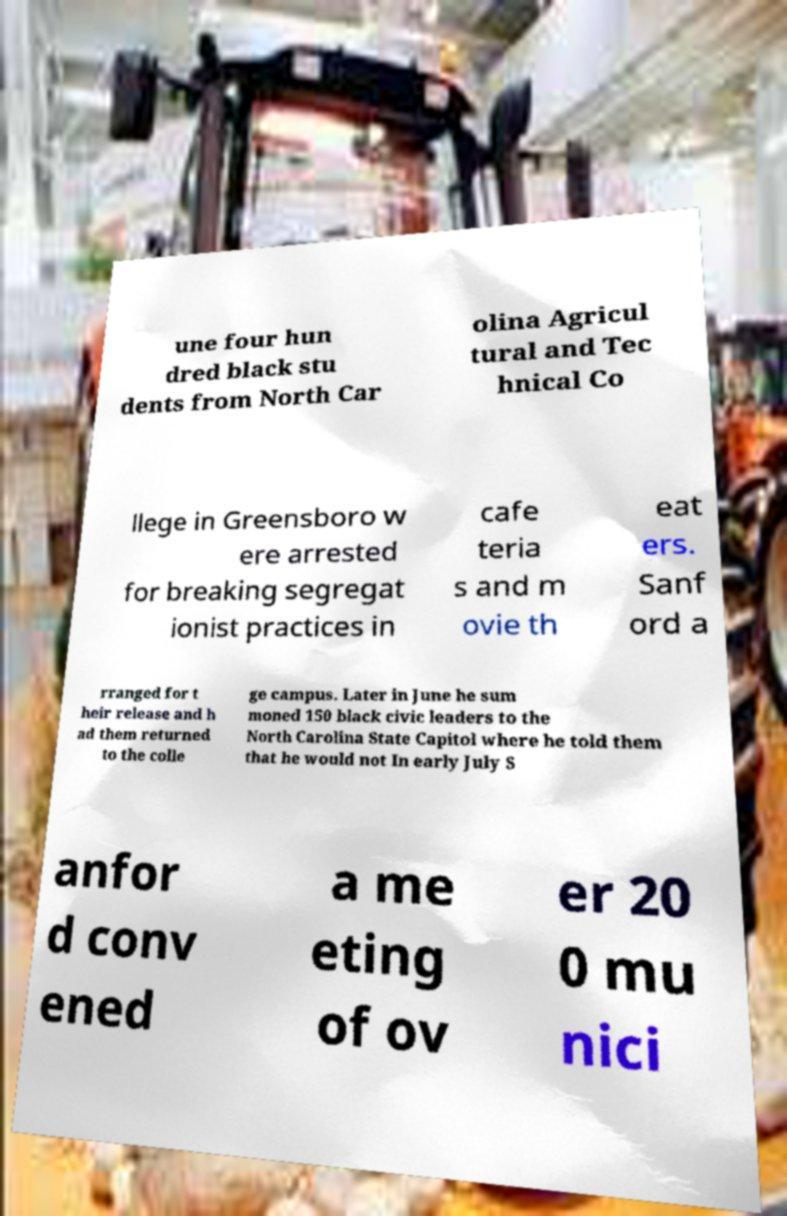For documentation purposes, I need the text within this image transcribed. Could you provide that? une four hun dred black stu dents from North Car olina Agricul tural and Tec hnical Co llege in Greensboro w ere arrested for breaking segregat ionist practices in cafe teria s and m ovie th eat ers. Sanf ord a rranged for t heir release and h ad them returned to the colle ge campus. Later in June he sum moned 150 black civic leaders to the North Carolina State Capitol where he told them that he would not In early July S anfor d conv ened a me eting of ov er 20 0 mu nici 